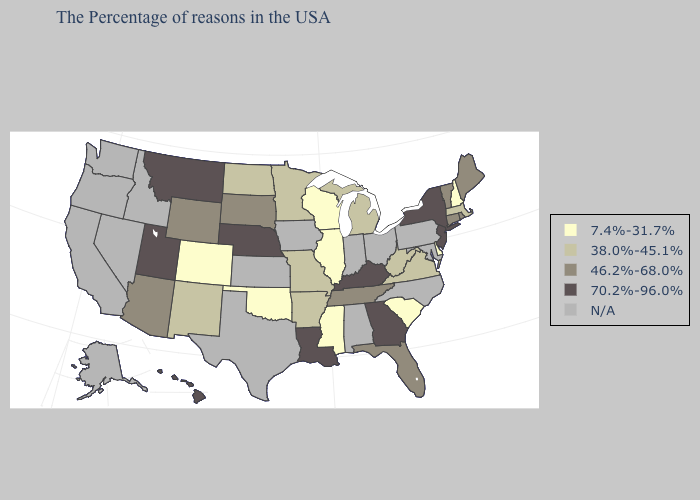Name the states that have a value in the range 70.2%-96.0%?
Quick response, please. New York, New Jersey, Georgia, Kentucky, Louisiana, Nebraska, Utah, Montana, Hawaii. Name the states that have a value in the range 38.0%-45.1%?
Be succinct. Massachusetts, Virginia, West Virginia, Michigan, Missouri, Arkansas, Minnesota, North Dakota, New Mexico. Name the states that have a value in the range 70.2%-96.0%?
Concise answer only. New York, New Jersey, Georgia, Kentucky, Louisiana, Nebraska, Utah, Montana, Hawaii. Does Colorado have the lowest value in the USA?
Be succinct. Yes. Name the states that have a value in the range 70.2%-96.0%?
Be succinct. New York, New Jersey, Georgia, Kentucky, Louisiana, Nebraska, Utah, Montana, Hawaii. Does Montana have the highest value in the West?
Be succinct. Yes. What is the value of Connecticut?
Write a very short answer. 46.2%-68.0%. Does South Dakota have the lowest value in the MidWest?
Quick response, please. No. What is the value of Texas?
Write a very short answer. N/A. Name the states that have a value in the range N/A?
Quick response, please. Maryland, Pennsylvania, North Carolina, Ohio, Indiana, Alabama, Iowa, Kansas, Texas, Idaho, Nevada, California, Washington, Oregon, Alaska. What is the value of South Dakota?
Be succinct. 46.2%-68.0%. Does the first symbol in the legend represent the smallest category?
Write a very short answer. Yes. Among the states that border Arkansas , which have the highest value?
Be succinct. Louisiana. Name the states that have a value in the range 7.4%-31.7%?
Write a very short answer. New Hampshire, Delaware, South Carolina, Wisconsin, Illinois, Mississippi, Oklahoma, Colorado. 